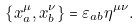Convert formula to latex. <formula><loc_0><loc_0><loc_500><loc_500>\left \{ x _ { a } ^ { \mu } , x _ { b } ^ { \nu } \right \} = \varepsilon _ { a b } \eta ^ { \mu \nu } .</formula> 